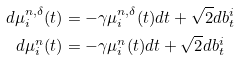Convert formula to latex. <formula><loc_0><loc_0><loc_500><loc_500>d \mu _ { i } ^ { n , \delta } ( t ) & = - \gamma \mu _ { i } ^ { n , \delta } ( t ) d t + \sqrt { 2 } d b ^ { i } _ { t } \, \\ d \mu _ { i } ^ { n } ( t ) & = - \gamma \mu _ { i } ^ { n } ( t ) d t + \sqrt { 2 } d b ^ { i } _ { t }</formula> 